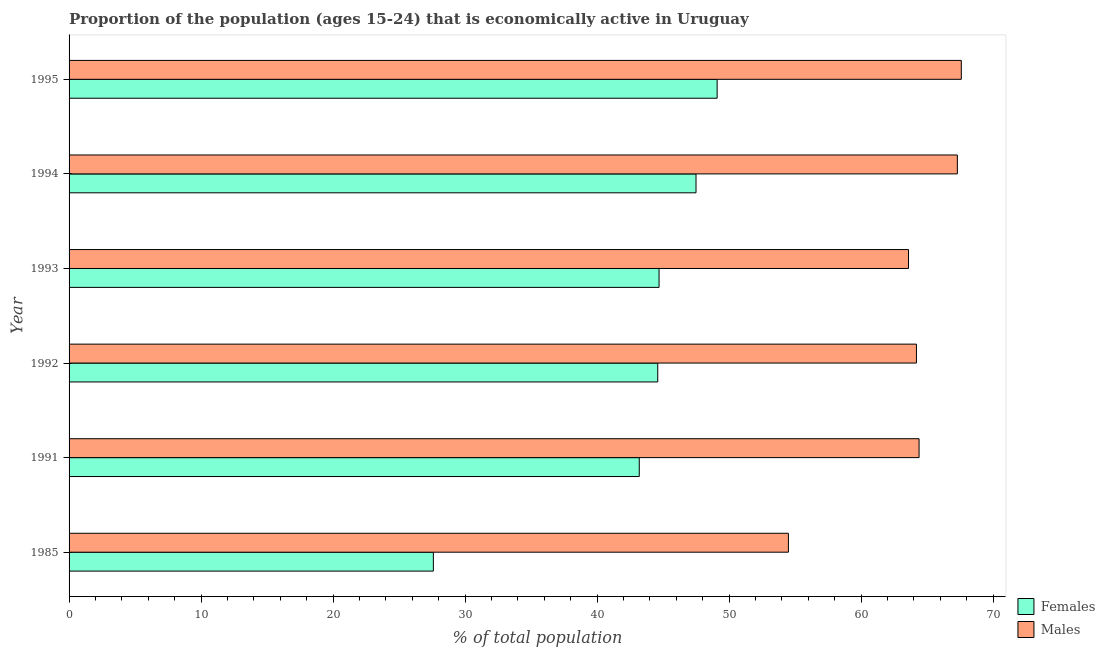How many different coloured bars are there?
Keep it short and to the point. 2. How many groups of bars are there?
Your response must be concise. 6. Are the number of bars per tick equal to the number of legend labels?
Provide a short and direct response. Yes. What is the label of the 1st group of bars from the top?
Keep it short and to the point. 1995. In how many cases, is the number of bars for a given year not equal to the number of legend labels?
Your answer should be very brief. 0. What is the percentage of economically active male population in 1991?
Your response must be concise. 64.4. Across all years, what is the maximum percentage of economically active female population?
Your response must be concise. 49.1. Across all years, what is the minimum percentage of economically active male population?
Your response must be concise. 54.5. In which year was the percentage of economically active female population maximum?
Your response must be concise. 1995. In which year was the percentage of economically active male population minimum?
Your answer should be very brief. 1985. What is the total percentage of economically active male population in the graph?
Provide a short and direct response. 381.6. What is the difference between the percentage of economically active male population in 1991 and that in 1993?
Provide a succinct answer. 0.8. What is the difference between the percentage of economically active male population in 1991 and the percentage of economically active female population in 1992?
Make the answer very short. 19.8. What is the average percentage of economically active female population per year?
Offer a very short reply. 42.78. In the year 1985, what is the difference between the percentage of economically active male population and percentage of economically active female population?
Your answer should be very brief. 26.9. What is the ratio of the percentage of economically active male population in 1985 to that in 1993?
Your answer should be very brief. 0.86. Is the percentage of economically active female population in 1993 less than that in 1994?
Provide a short and direct response. Yes. What is the difference between the highest and the lowest percentage of economically active male population?
Your answer should be very brief. 13.1. What does the 2nd bar from the top in 1985 represents?
Offer a terse response. Females. What does the 1st bar from the bottom in 1991 represents?
Give a very brief answer. Females. What is the difference between two consecutive major ticks on the X-axis?
Your response must be concise. 10. Does the graph contain grids?
Offer a terse response. No. Where does the legend appear in the graph?
Offer a very short reply. Bottom right. How are the legend labels stacked?
Ensure brevity in your answer.  Vertical. What is the title of the graph?
Your answer should be compact. Proportion of the population (ages 15-24) that is economically active in Uruguay. Does "Investment" appear as one of the legend labels in the graph?
Your answer should be very brief. No. What is the label or title of the X-axis?
Your answer should be very brief. % of total population. What is the label or title of the Y-axis?
Make the answer very short. Year. What is the % of total population of Females in 1985?
Give a very brief answer. 27.6. What is the % of total population of Males in 1985?
Your response must be concise. 54.5. What is the % of total population in Females in 1991?
Ensure brevity in your answer.  43.2. What is the % of total population in Males in 1991?
Your answer should be very brief. 64.4. What is the % of total population in Females in 1992?
Provide a succinct answer. 44.6. What is the % of total population of Males in 1992?
Give a very brief answer. 64.2. What is the % of total population of Females in 1993?
Your response must be concise. 44.7. What is the % of total population in Males in 1993?
Make the answer very short. 63.6. What is the % of total population of Females in 1994?
Give a very brief answer. 47.5. What is the % of total population in Males in 1994?
Keep it short and to the point. 67.3. What is the % of total population of Females in 1995?
Offer a very short reply. 49.1. What is the % of total population in Males in 1995?
Your response must be concise. 67.6. Across all years, what is the maximum % of total population of Females?
Give a very brief answer. 49.1. Across all years, what is the maximum % of total population in Males?
Offer a terse response. 67.6. Across all years, what is the minimum % of total population of Females?
Offer a terse response. 27.6. Across all years, what is the minimum % of total population of Males?
Make the answer very short. 54.5. What is the total % of total population of Females in the graph?
Provide a short and direct response. 256.7. What is the total % of total population in Males in the graph?
Offer a very short reply. 381.6. What is the difference between the % of total population of Females in 1985 and that in 1991?
Offer a terse response. -15.6. What is the difference between the % of total population of Females in 1985 and that in 1992?
Keep it short and to the point. -17. What is the difference between the % of total population of Females in 1985 and that in 1993?
Provide a succinct answer. -17.1. What is the difference between the % of total population in Females in 1985 and that in 1994?
Offer a very short reply. -19.9. What is the difference between the % of total population of Females in 1985 and that in 1995?
Your answer should be very brief. -21.5. What is the difference between the % of total population of Males in 1985 and that in 1995?
Your answer should be compact. -13.1. What is the difference between the % of total population of Males in 1991 and that in 1994?
Ensure brevity in your answer.  -2.9. What is the difference between the % of total population in Females in 1991 and that in 1995?
Keep it short and to the point. -5.9. What is the difference between the % of total population of Males in 1991 and that in 1995?
Your response must be concise. -3.2. What is the difference between the % of total population in Females in 1992 and that in 1993?
Keep it short and to the point. -0.1. What is the difference between the % of total population of Males in 1992 and that in 1993?
Your answer should be very brief. 0.6. What is the difference between the % of total population in Females in 1992 and that in 1994?
Your answer should be compact. -2.9. What is the difference between the % of total population in Females in 1992 and that in 1995?
Your response must be concise. -4.5. What is the difference between the % of total population of Males in 1992 and that in 1995?
Offer a terse response. -3.4. What is the difference between the % of total population in Males in 1993 and that in 1995?
Provide a succinct answer. -4. What is the difference between the % of total population of Females in 1985 and the % of total population of Males in 1991?
Provide a succinct answer. -36.8. What is the difference between the % of total population of Females in 1985 and the % of total population of Males in 1992?
Your answer should be very brief. -36.6. What is the difference between the % of total population in Females in 1985 and the % of total population in Males in 1993?
Ensure brevity in your answer.  -36. What is the difference between the % of total population in Females in 1985 and the % of total population in Males in 1994?
Your answer should be compact. -39.7. What is the difference between the % of total population of Females in 1985 and the % of total population of Males in 1995?
Keep it short and to the point. -40. What is the difference between the % of total population in Females in 1991 and the % of total population in Males in 1992?
Your answer should be very brief. -21. What is the difference between the % of total population in Females in 1991 and the % of total population in Males in 1993?
Keep it short and to the point. -20.4. What is the difference between the % of total population of Females in 1991 and the % of total population of Males in 1994?
Your answer should be very brief. -24.1. What is the difference between the % of total population in Females in 1991 and the % of total population in Males in 1995?
Provide a succinct answer. -24.4. What is the difference between the % of total population of Females in 1992 and the % of total population of Males in 1994?
Provide a succinct answer. -22.7. What is the difference between the % of total population in Females in 1993 and the % of total population in Males in 1994?
Give a very brief answer. -22.6. What is the difference between the % of total population in Females in 1993 and the % of total population in Males in 1995?
Make the answer very short. -22.9. What is the difference between the % of total population of Females in 1994 and the % of total population of Males in 1995?
Ensure brevity in your answer.  -20.1. What is the average % of total population of Females per year?
Your answer should be very brief. 42.78. What is the average % of total population of Males per year?
Ensure brevity in your answer.  63.6. In the year 1985, what is the difference between the % of total population of Females and % of total population of Males?
Your answer should be compact. -26.9. In the year 1991, what is the difference between the % of total population of Females and % of total population of Males?
Your answer should be compact. -21.2. In the year 1992, what is the difference between the % of total population of Females and % of total population of Males?
Your answer should be very brief. -19.6. In the year 1993, what is the difference between the % of total population in Females and % of total population in Males?
Keep it short and to the point. -18.9. In the year 1994, what is the difference between the % of total population of Females and % of total population of Males?
Your answer should be compact. -19.8. In the year 1995, what is the difference between the % of total population in Females and % of total population in Males?
Provide a short and direct response. -18.5. What is the ratio of the % of total population of Females in 1985 to that in 1991?
Provide a succinct answer. 0.64. What is the ratio of the % of total population in Males in 1985 to that in 1991?
Your response must be concise. 0.85. What is the ratio of the % of total population of Females in 1985 to that in 1992?
Your answer should be compact. 0.62. What is the ratio of the % of total population in Males in 1985 to that in 1992?
Offer a terse response. 0.85. What is the ratio of the % of total population in Females in 1985 to that in 1993?
Offer a terse response. 0.62. What is the ratio of the % of total population in Males in 1985 to that in 1993?
Your answer should be compact. 0.86. What is the ratio of the % of total population of Females in 1985 to that in 1994?
Give a very brief answer. 0.58. What is the ratio of the % of total population in Males in 1985 to that in 1994?
Offer a very short reply. 0.81. What is the ratio of the % of total population in Females in 1985 to that in 1995?
Make the answer very short. 0.56. What is the ratio of the % of total population in Males in 1985 to that in 1995?
Keep it short and to the point. 0.81. What is the ratio of the % of total population in Females in 1991 to that in 1992?
Provide a short and direct response. 0.97. What is the ratio of the % of total population in Males in 1991 to that in 1992?
Provide a short and direct response. 1. What is the ratio of the % of total population in Females in 1991 to that in 1993?
Offer a very short reply. 0.97. What is the ratio of the % of total population in Males in 1991 to that in 1993?
Ensure brevity in your answer.  1.01. What is the ratio of the % of total population of Females in 1991 to that in 1994?
Keep it short and to the point. 0.91. What is the ratio of the % of total population of Males in 1991 to that in 1994?
Give a very brief answer. 0.96. What is the ratio of the % of total population in Females in 1991 to that in 1995?
Provide a short and direct response. 0.88. What is the ratio of the % of total population of Males in 1991 to that in 1995?
Make the answer very short. 0.95. What is the ratio of the % of total population in Males in 1992 to that in 1993?
Offer a terse response. 1.01. What is the ratio of the % of total population in Females in 1992 to that in 1994?
Give a very brief answer. 0.94. What is the ratio of the % of total population in Males in 1992 to that in 1994?
Your response must be concise. 0.95. What is the ratio of the % of total population of Females in 1992 to that in 1995?
Provide a succinct answer. 0.91. What is the ratio of the % of total population in Males in 1992 to that in 1995?
Provide a succinct answer. 0.95. What is the ratio of the % of total population in Females in 1993 to that in 1994?
Your answer should be very brief. 0.94. What is the ratio of the % of total population of Males in 1993 to that in 1994?
Provide a succinct answer. 0.94. What is the ratio of the % of total population in Females in 1993 to that in 1995?
Provide a succinct answer. 0.91. What is the ratio of the % of total population of Males in 1993 to that in 1995?
Offer a terse response. 0.94. What is the ratio of the % of total population of Females in 1994 to that in 1995?
Make the answer very short. 0.97. What is the ratio of the % of total population in Males in 1994 to that in 1995?
Offer a very short reply. 1. 